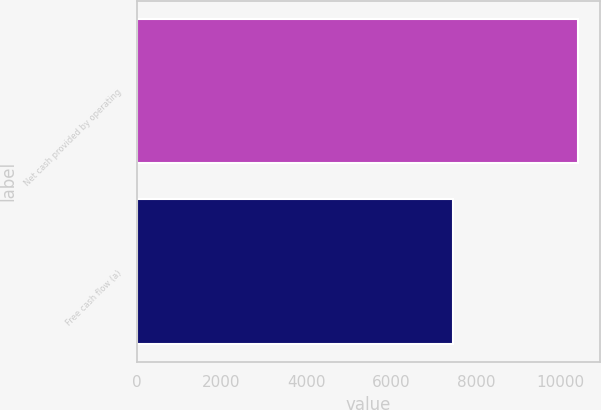Convert chart to OTSL. <chart><loc_0><loc_0><loc_500><loc_500><bar_chart><fcel>Net cash provided by operating<fcel>Free cash flow (a)<nl><fcel>10404<fcel>7463<nl></chart> 